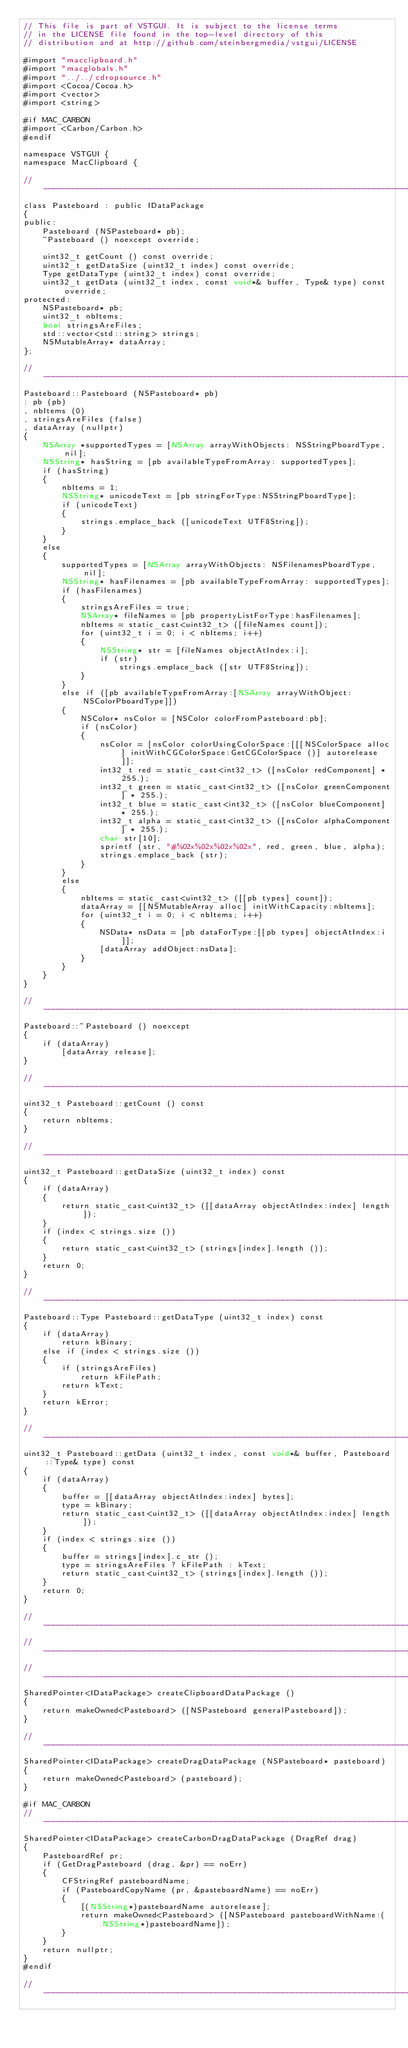<code> <loc_0><loc_0><loc_500><loc_500><_ObjectiveC_>// This file is part of VSTGUI. It is subject to the license terms 
// in the LICENSE file found in the top-level directory of this
// distribution and at http://github.com/steinbergmedia/vstgui/LICENSE

#import "macclipboard.h"
#import "macglobals.h"
#import "../../cdropsource.h"
#import <Cocoa/Cocoa.h>
#import <vector>
#import <string>

#if MAC_CARBON
#import <Carbon/Carbon.h>
#endif

namespace VSTGUI {
namespace MacClipboard {

//-----------------------------------------------------------------------------
class Pasteboard : public IDataPackage
{
public:
	Pasteboard (NSPasteboard* pb);
	~Pasteboard () noexcept override;

	uint32_t getCount () const override;
	uint32_t getDataSize (uint32_t index) const override;
	Type getDataType (uint32_t index) const override;
	uint32_t getData (uint32_t index, const void*& buffer, Type& type) const override;
protected:
	NSPasteboard* pb;
	uint32_t nbItems;
	bool stringsAreFiles;
	std::vector<std::string> strings;
	NSMutableArray* dataArray;
};

//-----------------------------------------------------------------------------
Pasteboard::Pasteboard (NSPasteboard* pb)
: pb (pb)
, nbItems (0)
, stringsAreFiles (false)
, dataArray (nullptr)
{
	NSArray *supportedTypes = [NSArray arrayWithObjects: NSStringPboardType, nil];
	NSString* hasString = [pb availableTypeFromArray: supportedTypes];
	if (hasString)
	{
		nbItems = 1;
		NSString* unicodeText = [pb stringForType:NSStringPboardType];
		if (unicodeText)
		{
			strings.emplace_back ([unicodeText UTF8String]);
		}
	}
	else
	{
		supportedTypes = [NSArray arrayWithObjects: NSFilenamesPboardType, nil];
		NSString* hasFilenames = [pb availableTypeFromArray: supportedTypes];
		if (hasFilenames)
		{
			stringsAreFiles = true;
			NSArray* fileNames = [pb propertyListForType:hasFilenames];
			nbItems = static_cast<uint32_t> ([fileNames count]);
			for (uint32_t i = 0; i < nbItems; i++)
			{
				NSString* str = [fileNames objectAtIndex:i];
				if (str)
					strings.emplace_back ([str UTF8String]);
			}
		}
		else if ([pb availableTypeFromArray:[NSArray arrayWithObject:NSColorPboardType]])
		{
			NSColor* nsColor = [NSColor colorFromPasteboard:pb];
			if (nsColor)
			{
				nsColor = [nsColor colorUsingColorSpace:[[[NSColorSpace alloc] initWithCGColorSpace:GetCGColorSpace ()] autorelease]];
				int32_t red = static_cast<int32_t> ([nsColor redComponent] * 255.);
				int32_t green = static_cast<int32_t> ([nsColor greenComponent] * 255.);
				int32_t blue = static_cast<int32_t> ([nsColor blueComponent] * 255.);
				int32_t alpha = static_cast<int32_t> ([nsColor alphaComponent] * 255.);
				char str[10];
				sprintf (str, "#%02x%02x%02x%02x", red, green, blue, alpha);
				strings.emplace_back (str);
			}
		}
		else
		{
			nbItems = static_cast<uint32_t> ([[pb types] count]);
			dataArray = [[NSMutableArray alloc] initWithCapacity:nbItems];
			for (uint32_t i = 0; i < nbItems; i++)
			{
				NSData* nsData = [pb dataForType:[[pb types] objectAtIndex:i]];
				[dataArray addObject:nsData];
			}
		}
	}
}

//-----------------------------------------------------------------------------
Pasteboard::~Pasteboard () noexcept
{
	if (dataArray)
		[dataArray release];
}

//-----------------------------------------------------------------------------
uint32_t Pasteboard::getCount () const
{
	return nbItems;
}

//-----------------------------------------------------------------------------
uint32_t Pasteboard::getDataSize (uint32_t index) const
{
	if (dataArray)
	{
		return static_cast<uint32_t> ([[dataArray objectAtIndex:index] length]);
	}
	if (index < strings.size ())
	{
		return static_cast<uint32_t> (strings[index].length ());
	}
	return 0;
}

//-----------------------------------------------------------------------------
Pasteboard::Type Pasteboard::getDataType (uint32_t index) const
{
	if (dataArray)
		return kBinary;
	else if (index < strings.size ())
	{
		if (stringsAreFiles)
			return kFilePath;
		return kText;
	}
	return kError;
}

//-----------------------------------------------------------------------------
uint32_t Pasteboard::getData (uint32_t index, const void*& buffer, Pasteboard::Type& type) const
{
	if (dataArray)
	{
		buffer = [[dataArray objectAtIndex:index] bytes];
		type = kBinary;
		return static_cast<uint32_t> ([[dataArray objectAtIndex:index] length]);
	}
	if (index < strings.size ())
	{
		buffer = strings[index].c_str ();
		type = stringsAreFiles ? kFilePath : kText;
		return static_cast<uint32_t> (strings[index].length ());
	}
	return 0;
}

//-----------------------------------------------------------------------------
//-----------------------------------------------------------------------------
//-----------------------------------------------------------------------------
SharedPointer<IDataPackage> createClipboardDataPackage ()
{
	return makeOwned<Pasteboard> ([NSPasteboard generalPasteboard]);
}

//-----------------------------------------------------------------------------
SharedPointer<IDataPackage> createDragDataPackage (NSPasteboard* pasteboard)
{
	return makeOwned<Pasteboard> (pasteboard);
}

#if MAC_CARBON
//-----------------------------------------------------------------------------
SharedPointer<IDataPackage> createCarbonDragDataPackage (DragRef drag)
{
	PasteboardRef pr;
	if (GetDragPasteboard (drag, &pr) == noErr)
	{
		CFStringRef pasteboardName;
		if (PasteboardCopyName (pr, &pasteboardName) == noErr)
		{
			[(NSString*)pasteboardName autorelease];
			return makeOwned<Pasteboard> ([NSPasteboard pasteboardWithName:(NSString*)pasteboardName]);
		}
	}
	return nullptr;
}
#endif

//-----------------------------------------------------------------------------</code> 